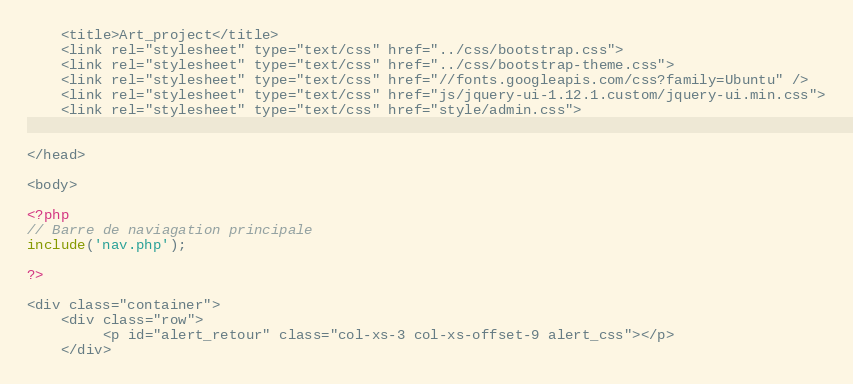<code> <loc_0><loc_0><loc_500><loc_500><_PHP_>	<title>Art_project</title>
    <link rel="stylesheet" type="text/css" href="../css/bootstrap.css">
    <link rel="stylesheet" type="text/css" href="../css/bootstrap-theme.css">
    <link rel="stylesheet" type="text/css" href="//fonts.googleapis.com/css?family=Ubuntu" />
    <link rel="stylesheet" type="text/css" href="js/jquery-ui-1.12.1.custom/jquery-ui.min.css">
	<link rel="stylesheet" type="text/css" href="style/admin.css">
    
    
</head>

<body>

<?php
// Barre de naviagation principale
include('nav.php');

?>

<div class="container">
    <div class="row">
         <p id="alert_retour" class="col-xs-3 col-xs-offset-9 alert_css"></p>
    </div>
</code> 